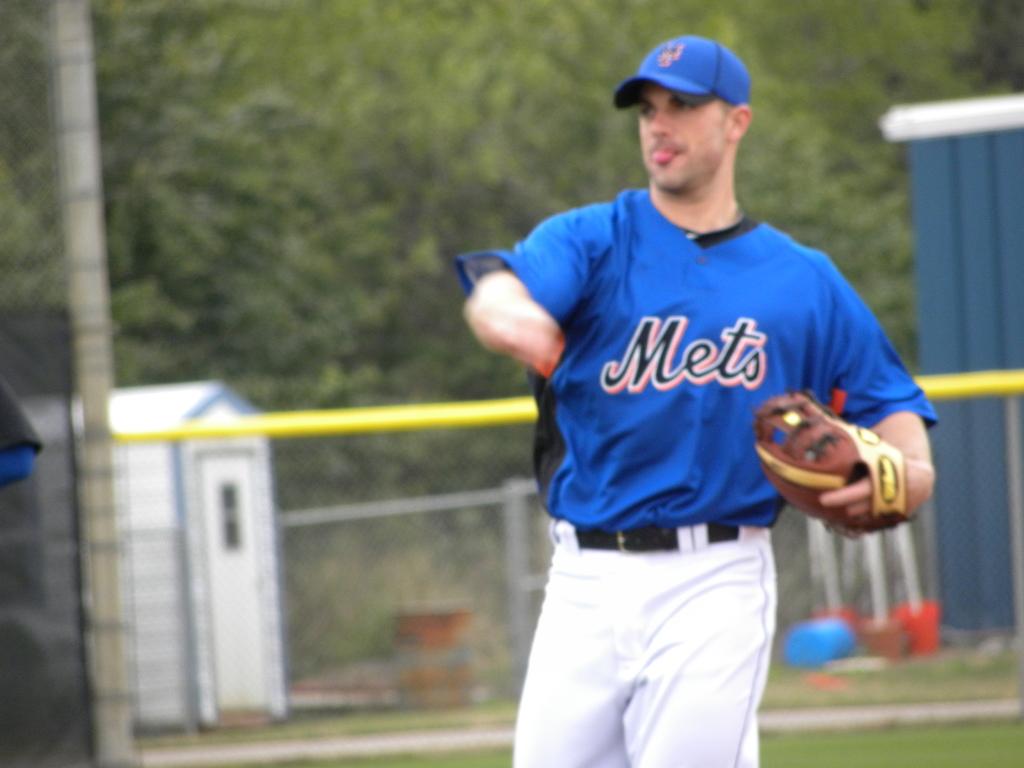What is the name of the baseball team?
Ensure brevity in your answer.  Mets. Is that man limbless?
Offer a terse response. Answering does not require reading text in the image. 